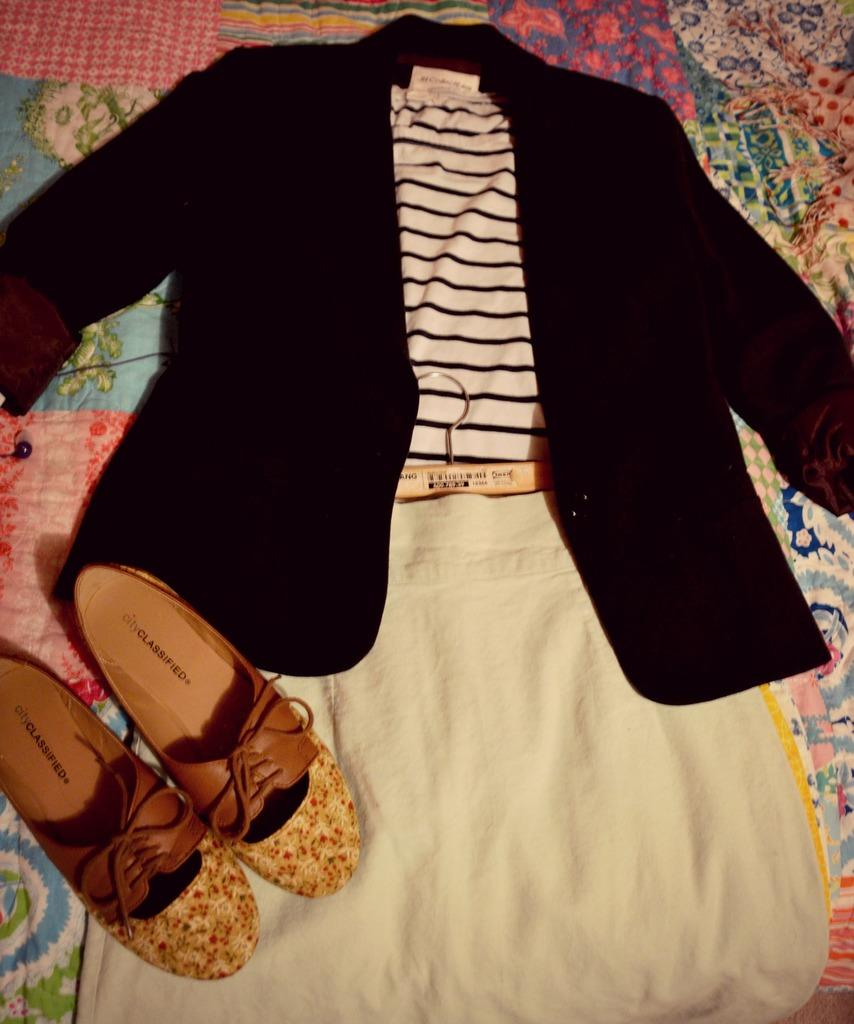Provide a one-sentence caption for the provided image. Two City Classified shoes are on top of a dress. 